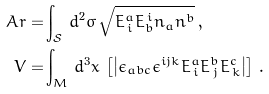<formula> <loc_0><loc_0><loc_500><loc_500>A r = & \int _ { \mathcal { S } } \, d ^ { 2 } \sigma \, \sqrt { E ^ { a } _ { \, i } E _ { b } ^ { \, i } n _ { a } n ^ { b } } \, , \\ V = & \int _ { M } \, d ^ { 3 } x \, \left [ \left | \epsilon _ { a b c } \epsilon ^ { i j k } E ^ { a } _ { \, i } E ^ { b } _ { \, j } E ^ { c } _ { \, k } \right | \right ] \, .</formula> 